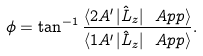<formula> <loc_0><loc_0><loc_500><loc_500>\phi = \tan ^ { - 1 } \frac { \langle 2 A ^ { \prime } | \hat { L } _ { z } | \ A p p \rangle } { \langle 1 A ^ { \prime } | \hat { L } _ { z } | \ A p p \rangle } .</formula> 